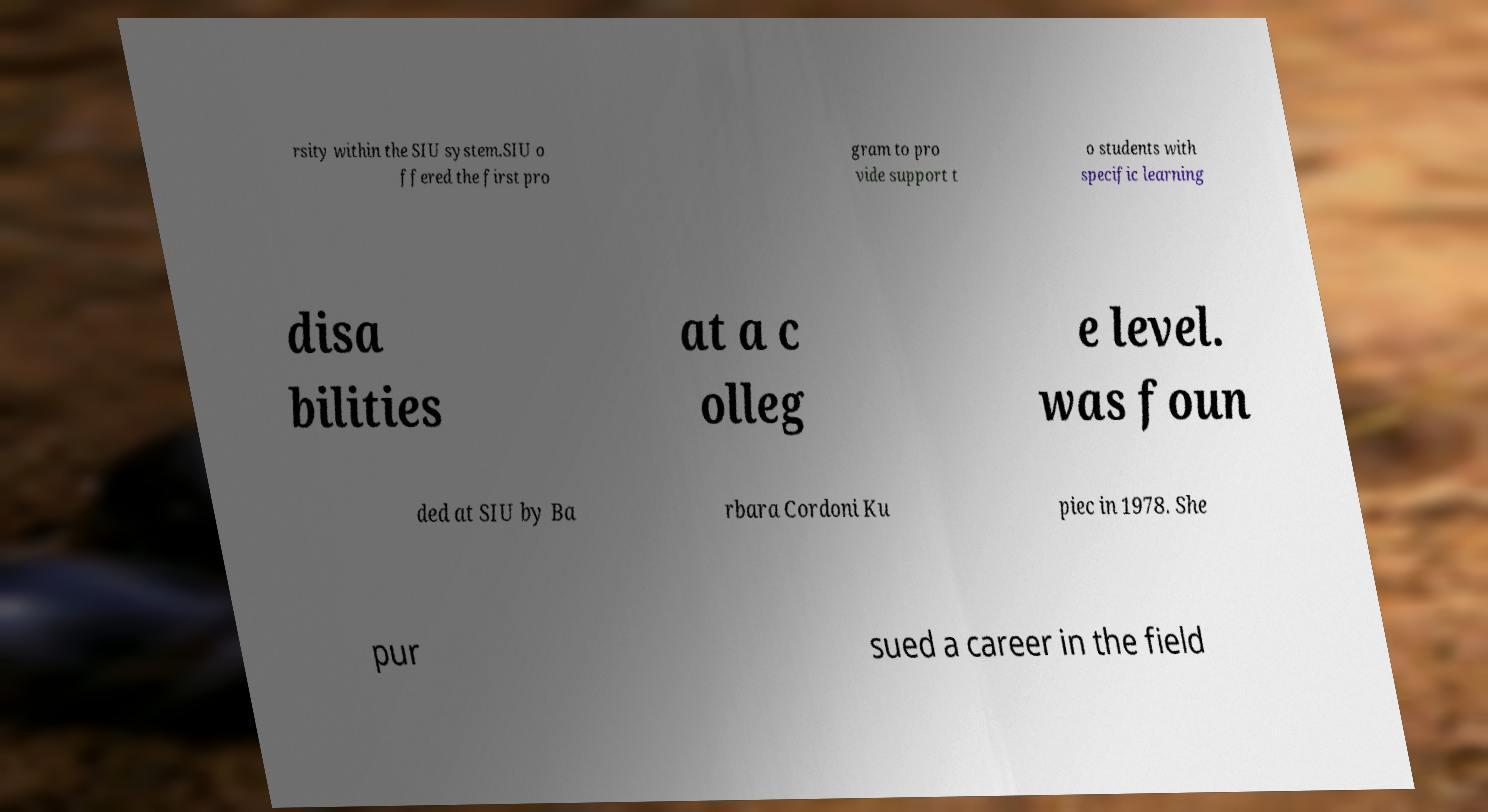Could you extract and type out the text from this image? rsity within the SIU system.SIU o ffered the first pro gram to pro vide support t o students with specific learning disa bilities at a c olleg e level. was foun ded at SIU by Ba rbara Cordoni Ku piec in 1978. She pur sued a career in the field 